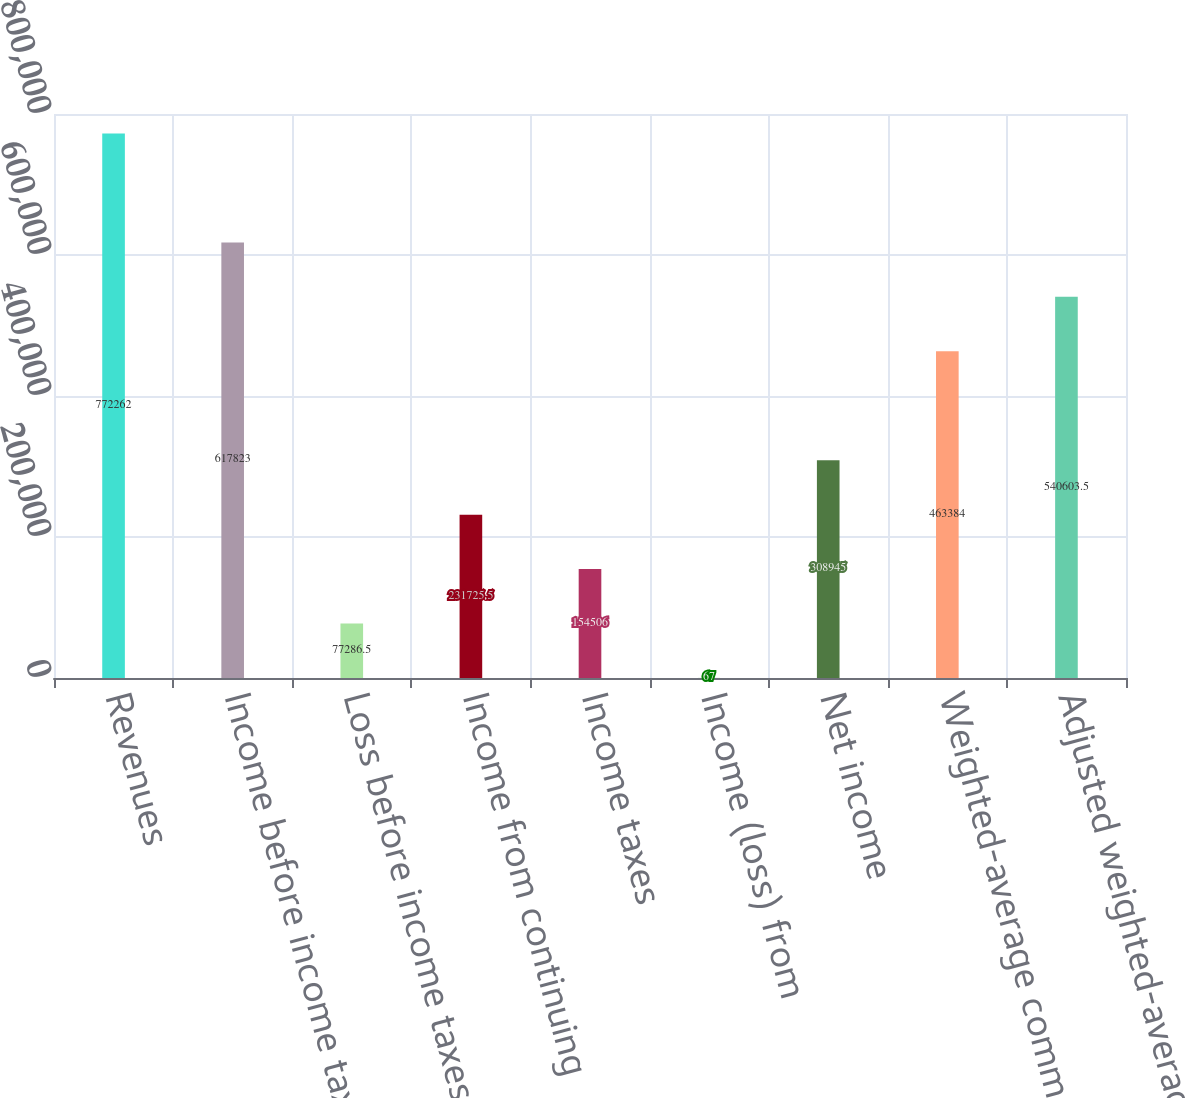<chart> <loc_0><loc_0><loc_500><loc_500><bar_chart><fcel>Revenues<fcel>Income before income taxes<fcel>Loss before income taxes<fcel>Income from continuing<fcel>Income taxes<fcel>Income (loss) from<fcel>Net income<fcel>Weighted-average common shares<fcel>Adjusted weighted-average<nl><fcel>772262<fcel>617823<fcel>77286.5<fcel>231726<fcel>154506<fcel>67<fcel>308945<fcel>463384<fcel>540604<nl></chart> 